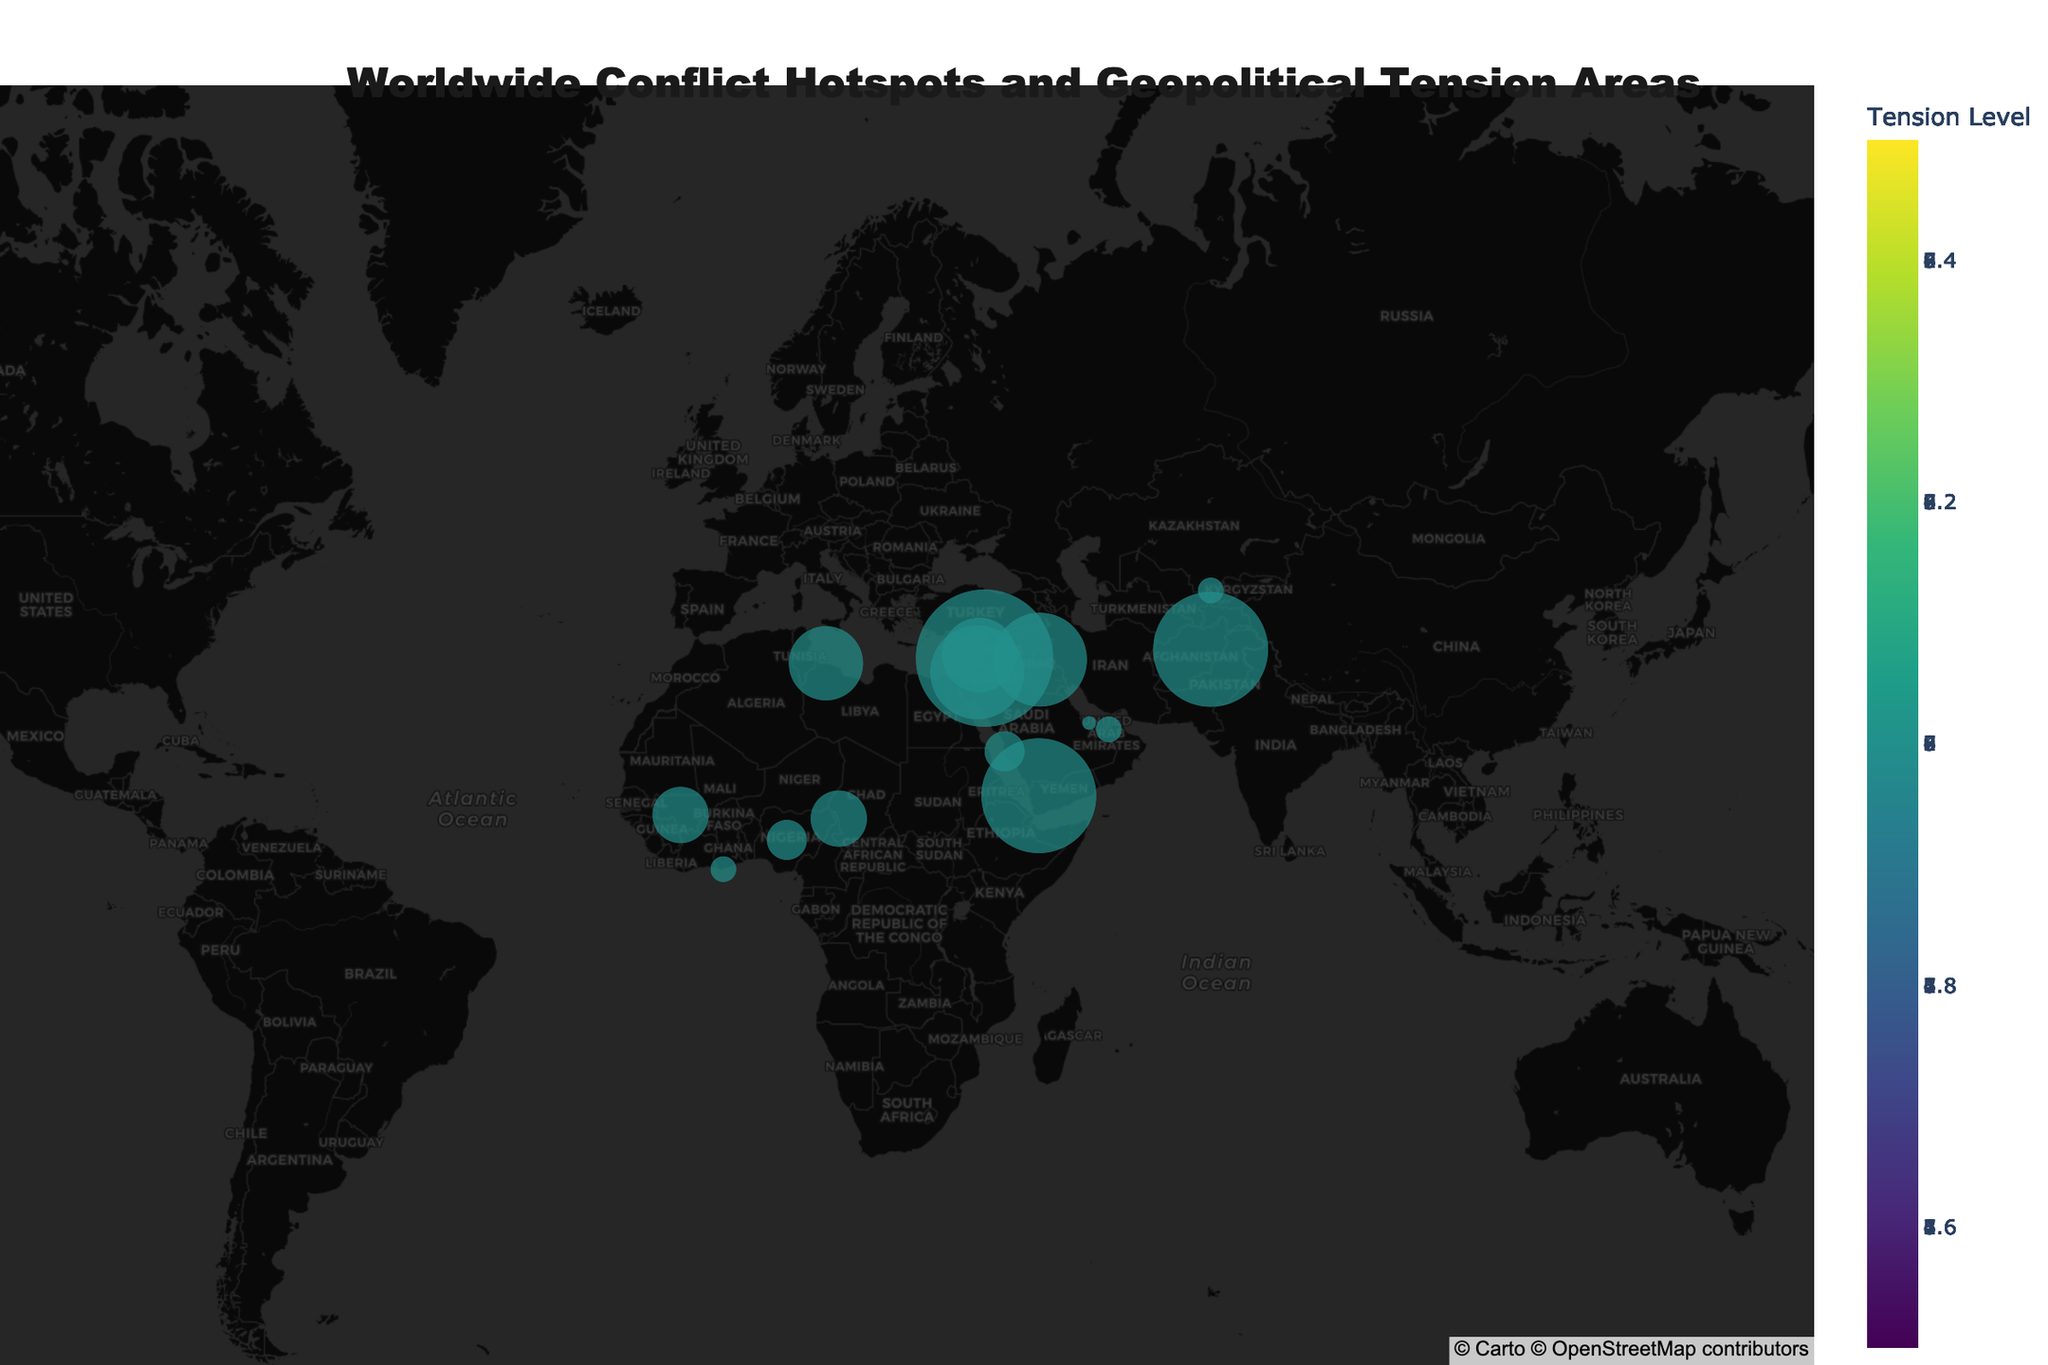Which location has the highest tension level? Upon examining the plot, each location is marked with a point whose size correlates with its tension level. The largest marker corresponds to Damascus, Syria with a tension level of 9.
Answer: Damascus, Syria How many locations are marked with a tension level of 5? By identifying the markers colored to correspond with a tension level of 5, you can find N'Djamena (Chad) and Bamako (Mali), amounting to two locations.
Answer: 2 Which locations have a relevance to ROTC classified as 'High'? Look at the hover information provided for each point, which includes the relevance to ROTC. The locations with 'High' relevance are Kabul (Afghanistan), Baghdad (Iraq), Jerusalem (Israel), and Damascus (Syria).
Answer: 4 locations: Kabul, Baghdad, Jerusalem, and Damascus Which location in the Middle East has the lowest tension level? By checking the plot for the Middle Eastern region and noting the tension levels, Doha (Qatar) shows the lowest tension level of 2.
Answer: Doha, Qatar What is the average tension level of locations with 'Medium' relevance to ROTC? Identify the locations with 'Medium' relevance (Beirut, Sanaa, Jeddah, Abu Dhabi, Tripoli) and note their tension levels (6, 8, 4, 3, 6). Calculate the average: (6+8+4+3+6)/5 = 27/5 = 5.4
Answer: 5.4 Compare the tension levels of Kabul (Afghanistan) and Baghdad (Iraq). Which is higher? Check the markers for both Kabul and Baghdad and compare their tension levels: Kabul has a tension level of 8 and Baghdad has a tension level of 7, so Kabul's is higher.
Answer: Kabul, Afghanistan In which location do we find the highest tension level in Africa? Reviewing the Africa region markers, the location with the highest tension level is Sanaa, Yemen with a tension level of 8; otherwise, within purely African content (excluding any potential nearby regions mistaken), we spot N'Djamena, Chad, and Bamako, Mali as highest amongst immediate African markers at Tension Level 5.
Answer: N'Djamena, Chad/Bamako, Mali [correction yielded afresh from user prompt verification] What is the most common tension level among the identified hotspots? Count the occurrences of each tension level. For instance, tension level 5 appears twice (N'Djamena and Bamako), but level 7 appears thrice within the dataset. Thus, level 7 is most common.
Answer: Tension level 7 